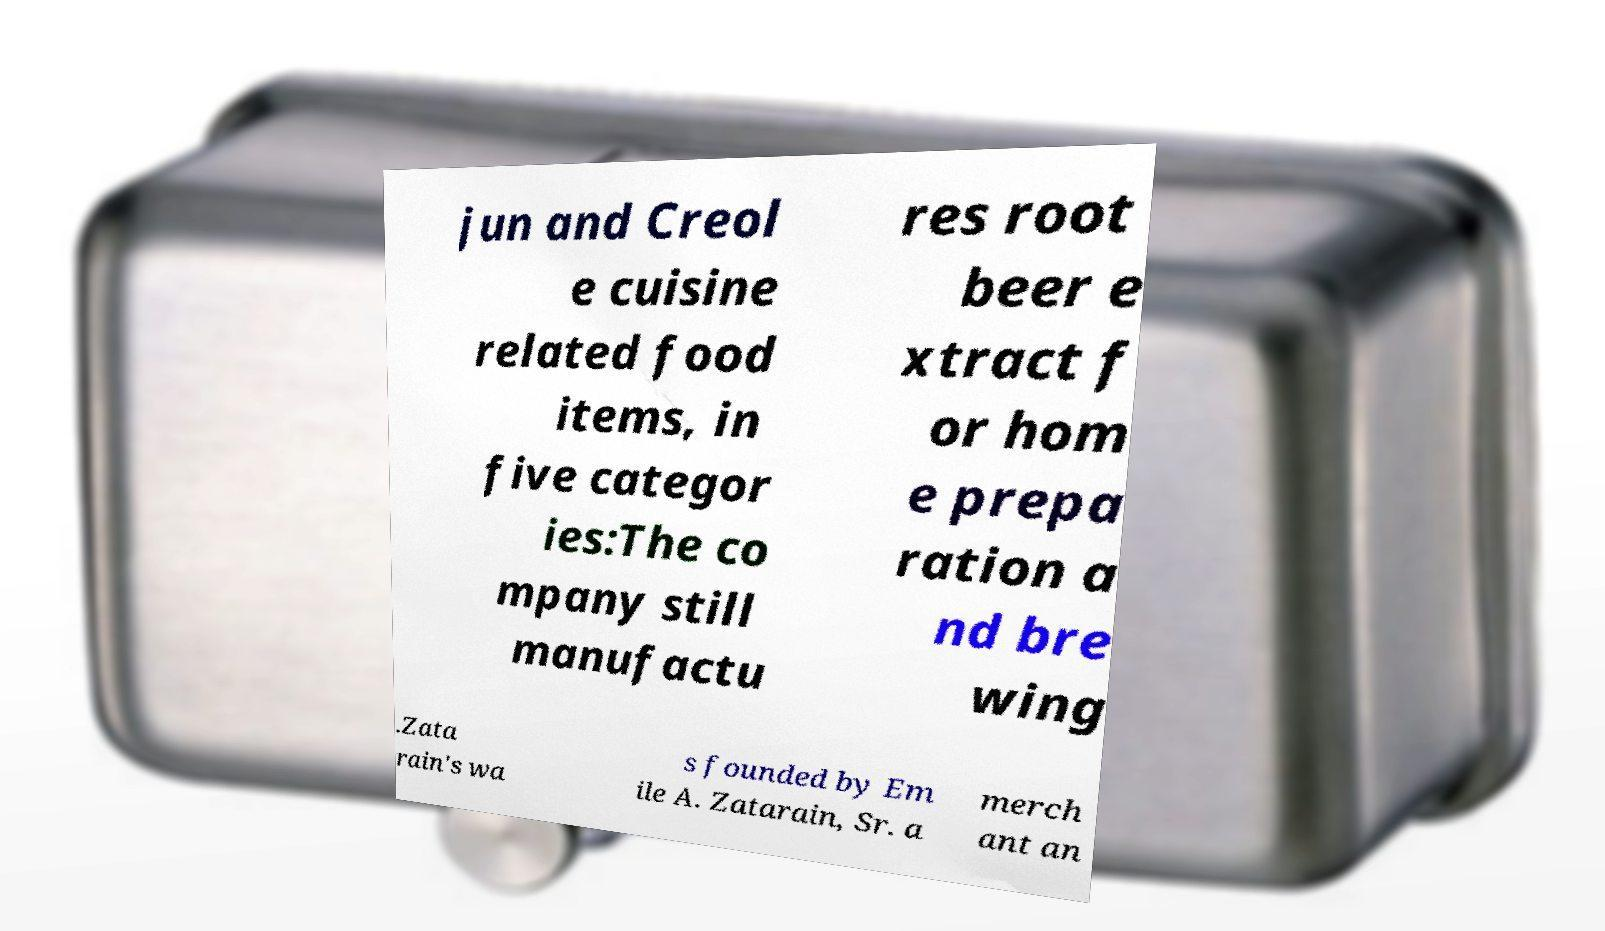I need the written content from this picture converted into text. Can you do that? jun and Creol e cuisine related food items, in five categor ies:The co mpany still manufactu res root beer e xtract f or hom e prepa ration a nd bre wing .Zata rain's wa s founded by Em ile A. Zatarain, Sr. a merch ant an 